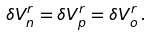<formula> <loc_0><loc_0><loc_500><loc_500>\delta V ^ { r } _ { n } = \delta V ^ { r } _ { p } = \delta V ^ { r } _ { o } \, .</formula> 